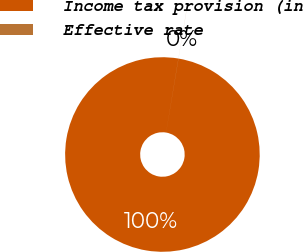Convert chart. <chart><loc_0><loc_0><loc_500><loc_500><pie_chart><fcel>Income tax provision (in<fcel>Effective rate<nl><fcel>99.99%<fcel>0.01%<nl></chart> 